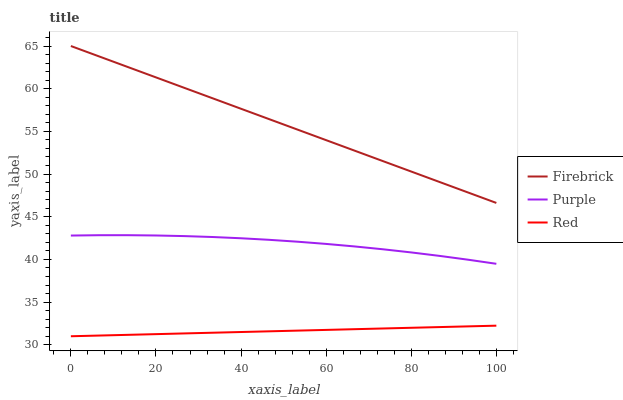Does Red have the minimum area under the curve?
Answer yes or no. Yes. Does Firebrick have the maximum area under the curve?
Answer yes or no. Yes. Does Firebrick have the minimum area under the curve?
Answer yes or no. No. Does Red have the maximum area under the curve?
Answer yes or no. No. Is Red the smoothest?
Answer yes or no. Yes. Is Purple the roughest?
Answer yes or no. Yes. Is Firebrick the smoothest?
Answer yes or no. No. Is Firebrick the roughest?
Answer yes or no. No. Does Red have the lowest value?
Answer yes or no. Yes. Does Firebrick have the lowest value?
Answer yes or no. No. Does Firebrick have the highest value?
Answer yes or no. Yes. Does Red have the highest value?
Answer yes or no. No. Is Red less than Firebrick?
Answer yes or no. Yes. Is Firebrick greater than Purple?
Answer yes or no. Yes. Does Red intersect Firebrick?
Answer yes or no. No. 